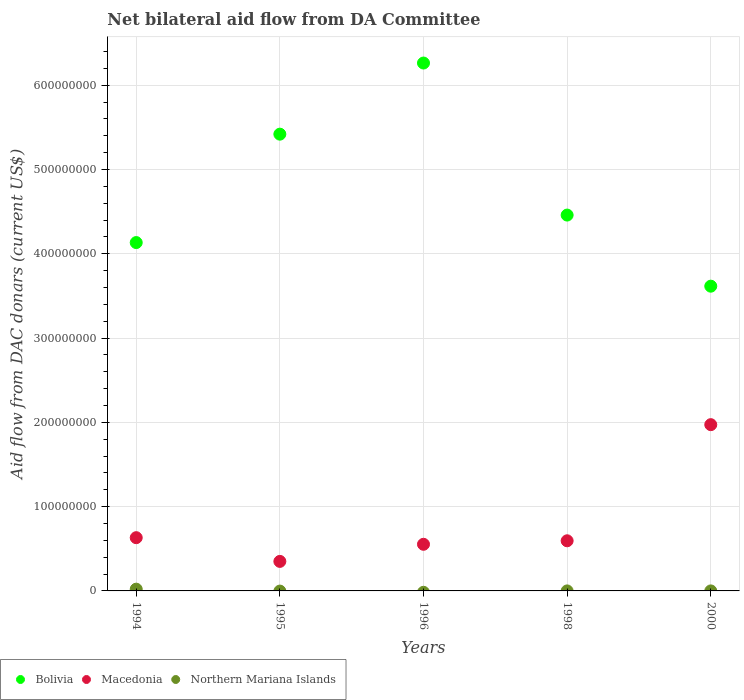How many different coloured dotlines are there?
Your answer should be compact. 3. What is the aid flow in in Bolivia in 1995?
Provide a succinct answer. 5.42e+08. Across all years, what is the maximum aid flow in in Macedonia?
Your answer should be compact. 1.97e+08. Across all years, what is the minimum aid flow in in Macedonia?
Your response must be concise. 3.50e+07. In which year was the aid flow in in Macedonia maximum?
Offer a very short reply. 2000. What is the total aid flow in in Bolivia in the graph?
Give a very brief answer. 2.39e+09. What is the difference between the aid flow in in Macedonia in 1994 and that in 2000?
Make the answer very short. -1.34e+08. What is the difference between the aid flow in in Northern Mariana Islands in 2000 and the aid flow in in Macedonia in 1996?
Keep it short and to the point. -5.53e+07. What is the average aid flow in in Macedonia per year?
Keep it short and to the point. 8.21e+07. In the year 1995, what is the difference between the aid flow in in Macedonia and aid flow in in Bolivia?
Provide a short and direct response. -5.07e+08. In how many years, is the aid flow in in Northern Mariana Islands greater than 440000000 US$?
Your answer should be very brief. 0. What is the ratio of the aid flow in in Bolivia in 1994 to that in 1995?
Your response must be concise. 0.76. Is the difference between the aid flow in in Macedonia in 1994 and 1995 greater than the difference between the aid flow in in Bolivia in 1994 and 1995?
Ensure brevity in your answer.  Yes. What is the difference between the highest and the second highest aid flow in in Northern Mariana Islands?
Provide a short and direct response. 2.07e+06. What is the difference between the highest and the lowest aid flow in in Northern Mariana Islands?
Your answer should be compact. 2.08e+06. Is the sum of the aid flow in in Bolivia in 1996 and 2000 greater than the maximum aid flow in in Northern Mariana Islands across all years?
Provide a short and direct response. Yes. Is the aid flow in in Northern Mariana Islands strictly less than the aid flow in in Bolivia over the years?
Ensure brevity in your answer.  Yes. How many dotlines are there?
Provide a short and direct response. 3. What is the difference between two consecutive major ticks on the Y-axis?
Provide a succinct answer. 1.00e+08. Does the graph contain grids?
Offer a terse response. Yes. Where does the legend appear in the graph?
Your answer should be very brief. Bottom left. How many legend labels are there?
Keep it short and to the point. 3. How are the legend labels stacked?
Provide a succinct answer. Horizontal. What is the title of the graph?
Give a very brief answer. Net bilateral aid flow from DA Committee. What is the label or title of the Y-axis?
Offer a very short reply. Aid flow from DAC donars (current US$). What is the Aid flow from DAC donars (current US$) of Bolivia in 1994?
Provide a succinct answer. 4.13e+08. What is the Aid flow from DAC donars (current US$) of Macedonia in 1994?
Provide a succinct answer. 6.32e+07. What is the Aid flow from DAC donars (current US$) of Northern Mariana Islands in 1994?
Your answer should be compact. 2.08e+06. What is the Aid flow from DAC donars (current US$) of Bolivia in 1995?
Keep it short and to the point. 5.42e+08. What is the Aid flow from DAC donars (current US$) in Macedonia in 1995?
Give a very brief answer. 3.50e+07. What is the Aid flow from DAC donars (current US$) of Bolivia in 1996?
Provide a short and direct response. 6.26e+08. What is the Aid flow from DAC donars (current US$) of Macedonia in 1996?
Offer a terse response. 5.53e+07. What is the Aid flow from DAC donars (current US$) in Bolivia in 1998?
Keep it short and to the point. 4.46e+08. What is the Aid flow from DAC donars (current US$) in Macedonia in 1998?
Give a very brief answer. 5.95e+07. What is the Aid flow from DAC donars (current US$) of Bolivia in 2000?
Provide a short and direct response. 3.62e+08. What is the Aid flow from DAC donars (current US$) of Macedonia in 2000?
Your answer should be compact. 1.97e+08. Across all years, what is the maximum Aid flow from DAC donars (current US$) in Bolivia?
Offer a terse response. 6.26e+08. Across all years, what is the maximum Aid flow from DAC donars (current US$) in Macedonia?
Offer a terse response. 1.97e+08. Across all years, what is the maximum Aid flow from DAC donars (current US$) of Northern Mariana Islands?
Provide a succinct answer. 2.08e+06. Across all years, what is the minimum Aid flow from DAC donars (current US$) in Bolivia?
Your answer should be very brief. 3.62e+08. Across all years, what is the minimum Aid flow from DAC donars (current US$) of Macedonia?
Your response must be concise. 3.50e+07. What is the total Aid flow from DAC donars (current US$) in Bolivia in the graph?
Offer a terse response. 2.39e+09. What is the total Aid flow from DAC donars (current US$) of Macedonia in the graph?
Your answer should be compact. 4.10e+08. What is the total Aid flow from DAC donars (current US$) of Northern Mariana Islands in the graph?
Provide a short and direct response. 2.10e+06. What is the difference between the Aid flow from DAC donars (current US$) of Bolivia in 1994 and that in 1995?
Provide a succinct answer. -1.29e+08. What is the difference between the Aid flow from DAC donars (current US$) in Macedonia in 1994 and that in 1995?
Make the answer very short. 2.82e+07. What is the difference between the Aid flow from DAC donars (current US$) in Bolivia in 1994 and that in 1996?
Provide a short and direct response. -2.13e+08. What is the difference between the Aid flow from DAC donars (current US$) in Macedonia in 1994 and that in 1996?
Offer a terse response. 7.84e+06. What is the difference between the Aid flow from DAC donars (current US$) in Bolivia in 1994 and that in 1998?
Make the answer very short. -3.26e+07. What is the difference between the Aid flow from DAC donars (current US$) in Macedonia in 1994 and that in 1998?
Provide a short and direct response. 3.69e+06. What is the difference between the Aid flow from DAC donars (current US$) in Northern Mariana Islands in 1994 and that in 1998?
Your answer should be compact. 2.07e+06. What is the difference between the Aid flow from DAC donars (current US$) in Bolivia in 1994 and that in 2000?
Offer a very short reply. 5.18e+07. What is the difference between the Aid flow from DAC donars (current US$) in Macedonia in 1994 and that in 2000?
Offer a terse response. -1.34e+08. What is the difference between the Aid flow from DAC donars (current US$) in Northern Mariana Islands in 1994 and that in 2000?
Your answer should be very brief. 2.07e+06. What is the difference between the Aid flow from DAC donars (current US$) in Bolivia in 1995 and that in 1996?
Provide a succinct answer. -8.44e+07. What is the difference between the Aid flow from DAC donars (current US$) of Macedonia in 1995 and that in 1996?
Keep it short and to the point. -2.03e+07. What is the difference between the Aid flow from DAC donars (current US$) of Bolivia in 1995 and that in 1998?
Provide a short and direct response. 9.60e+07. What is the difference between the Aid flow from DAC donars (current US$) of Macedonia in 1995 and that in 1998?
Your answer should be very brief. -2.45e+07. What is the difference between the Aid flow from DAC donars (current US$) of Bolivia in 1995 and that in 2000?
Offer a very short reply. 1.80e+08. What is the difference between the Aid flow from DAC donars (current US$) in Macedonia in 1995 and that in 2000?
Keep it short and to the point. -1.62e+08. What is the difference between the Aid flow from DAC donars (current US$) of Bolivia in 1996 and that in 1998?
Offer a very short reply. 1.80e+08. What is the difference between the Aid flow from DAC donars (current US$) in Macedonia in 1996 and that in 1998?
Your response must be concise. -4.15e+06. What is the difference between the Aid flow from DAC donars (current US$) of Bolivia in 1996 and that in 2000?
Your response must be concise. 2.65e+08. What is the difference between the Aid flow from DAC donars (current US$) in Macedonia in 1996 and that in 2000?
Offer a very short reply. -1.42e+08. What is the difference between the Aid flow from DAC donars (current US$) of Bolivia in 1998 and that in 2000?
Give a very brief answer. 8.44e+07. What is the difference between the Aid flow from DAC donars (current US$) of Macedonia in 1998 and that in 2000?
Offer a terse response. -1.38e+08. What is the difference between the Aid flow from DAC donars (current US$) in Bolivia in 1994 and the Aid flow from DAC donars (current US$) in Macedonia in 1995?
Give a very brief answer. 3.78e+08. What is the difference between the Aid flow from DAC donars (current US$) of Bolivia in 1994 and the Aid flow from DAC donars (current US$) of Macedonia in 1996?
Keep it short and to the point. 3.58e+08. What is the difference between the Aid flow from DAC donars (current US$) of Bolivia in 1994 and the Aid flow from DAC donars (current US$) of Macedonia in 1998?
Give a very brief answer. 3.54e+08. What is the difference between the Aid flow from DAC donars (current US$) of Bolivia in 1994 and the Aid flow from DAC donars (current US$) of Northern Mariana Islands in 1998?
Make the answer very short. 4.13e+08. What is the difference between the Aid flow from DAC donars (current US$) in Macedonia in 1994 and the Aid flow from DAC donars (current US$) in Northern Mariana Islands in 1998?
Give a very brief answer. 6.32e+07. What is the difference between the Aid flow from DAC donars (current US$) in Bolivia in 1994 and the Aid flow from DAC donars (current US$) in Macedonia in 2000?
Provide a succinct answer. 2.16e+08. What is the difference between the Aid flow from DAC donars (current US$) in Bolivia in 1994 and the Aid flow from DAC donars (current US$) in Northern Mariana Islands in 2000?
Your answer should be very brief. 4.13e+08. What is the difference between the Aid flow from DAC donars (current US$) in Macedonia in 1994 and the Aid flow from DAC donars (current US$) in Northern Mariana Islands in 2000?
Your response must be concise. 6.32e+07. What is the difference between the Aid flow from DAC donars (current US$) in Bolivia in 1995 and the Aid flow from DAC donars (current US$) in Macedonia in 1996?
Ensure brevity in your answer.  4.87e+08. What is the difference between the Aid flow from DAC donars (current US$) of Bolivia in 1995 and the Aid flow from DAC donars (current US$) of Macedonia in 1998?
Ensure brevity in your answer.  4.83e+08. What is the difference between the Aid flow from DAC donars (current US$) in Bolivia in 1995 and the Aid flow from DAC donars (current US$) in Northern Mariana Islands in 1998?
Keep it short and to the point. 5.42e+08. What is the difference between the Aid flow from DAC donars (current US$) of Macedonia in 1995 and the Aid flow from DAC donars (current US$) of Northern Mariana Islands in 1998?
Provide a succinct answer. 3.50e+07. What is the difference between the Aid flow from DAC donars (current US$) in Bolivia in 1995 and the Aid flow from DAC donars (current US$) in Macedonia in 2000?
Your answer should be very brief. 3.45e+08. What is the difference between the Aid flow from DAC donars (current US$) in Bolivia in 1995 and the Aid flow from DAC donars (current US$) in Northern Mariana Islands in 2000?
Your answer should be very brief. 5.42e+08. What is the difference between the Aid flow from DAC donars (current US$) of Macedonia in 1995 and the Aid flow from DAC donars (current US$) of Northern Mariana Islands in 2000?
Make the answer very short. 3.50e+07. What is the difference between the Aid flow from DAC donars (current US$) in Bolivia in 1996 and the Aid flow from DAC donars (current US$) in Macedonia in 1998?
Offer a terse response. 5.67e+08. What is the difference between the Aid flow from DAC donars (current US$) in Bolivia in 1996 and the Aid flow from DAC donars (current US$) in Northern Mariana Islands in 1998?
Provide a succinct answer. 6.26e+08. What is the difference between the Aid flow from DAC donars (current US$) of Macedonia in 1996 and the Aid flow from DAC donars (current US$) of Northern Mariana Islands in 1998?
Provide a short and direct response. 5.53e+07. What is the difference between the Aid flow from DAC donars (current US$) in Bolivia in 1996 and the Aid flow from DAC donars (current US$) in Macedonia in 2000?
Make the answer very short. 4.29e+08. What is the difference between the Aid flow from DAC donars (current US$) of Bolivia in 1996 and the Aid flow from DAC donars (current US$) of Northern Mariana Islands in 2000?
Keep it short and to the point. 6.26e+08. What is the difference between the Aid flow from DAC donars (current US$) in Macedonia in 1996 and the Aid flow from DAC donars (current US$) in Northern Mariana Islands in 2000?
Make the answer very short. 5.53e+07. What is the difference between the Aid flow from DAC donars (current US$) in Bolivia in 1998 and the Aid flow from DAC donars (current US$) in Macedonia in 2000?
Ensure brevity in your answer.  2.49e+08. What is the difference between the Aid flow from DAC donars (current US$) of Bolivia in 1998 and the Aid flow from DAC donars (current US$) of Northern Mariana Islands in 2000?
Ensure brevity in your answer.  4.46e+08. What is the difference between the Aid flow from DAC donars (current US$) of Macedonia in 1998 and the Aid flow from DAC donars (current US$) of Northern Mariana Islands in 2000?
Your response must be concise. 5.95e+07. What is the average Aid flow from DAC donars (current US$) of Bolivia per year?
Offer a very short reply. 4.78e+08. What is the average Aid flow from DAC donars (current US$) of Macedonia per year?
Make the answer very short. 8.21e+07. What is the average Aid flow from DAC donars (current US$) in Northern Mariana Islands per year?
Ensure brevity in your answer.  4.20e+05. In the year 1994, what is the difference between the Aid flow from DAC donars (current US$) in Bolivia and Aid flow from DAC donars (current US$) in Macedonia?
Your answer should be compact. 3.50e+08. In the year 1994, what is the difference between the Aid flow from DAC donars (current US$) in Bolivia and Aid flow from DAC donars (current US$) in Northern Mariana Islands?
Ensure brevity in your answer.  4.11e+08. In the year 1994, what is the difference between the Aid flow from DAC donars (current US$) in Macedonia and Aid flow from DAC donars (current US$) in Northern Mariana Islands?
Provide a succinct answer. 6.11e+07. In the year 1995, what is the difference between the Aid flow from DAC donars (current US$) in Bolivia and Aid flow from DAC donars (current US$) in Macedonia?
Offer a very short reply. 5.07e+08. In the year 1996, what is the difference between the Aid flow from DAC donars (current US$) in Bolivia and Aid flow from DAC donars (current US$) in Macedonia?
Your response must be concise. 5.71e+08. In the year 1998, what is the difference between the Aid flow from DAC donars (current US$) of Bolivia and Aid flow from DAC donars (current US$) of Macedonia?
Offer a very short reply. 3.86e+08. In the year 1998, what is the difference between the Aid flow from DAC donars (current US$) of Bolivia and Aid flow from DAC donars (current US$) of Northern Mariana Islands?
Provide a succinct answer. 4.46e+08. In the year 1998, what is the difference between the Aid flow from DAC donars (current US$) of Macedonia and Aid flow from DAC donars (current US$) of Northern Mariana Islands?
Your response must be concise. 5.95e+07. In the year 2000, what is the difference between the Aid flow from DAC donars (current US$) in Bolivia and Aid flow from DAC donars (current US$) in Macedonia?
Offer a terse response. 1.64e+08. In the year 2000, what is the difference between the Aid flow from DAC donars (current US$) in Bolivia and Aid flow from DAC donars (current US$) in Northern Mariana Islands?
Offer a terse response. 3.62e+08. In the year 2000, what is the difference between the Aid flow from DAC donars (current US$) of Macedonia and Aid flow from DAC donars (current US$) of Northern Mariana Islands?
Ensure brevity in your answer.  1.97e+08. What is the ratio of the Aid flow from DAC donars (current US$) in Bolivia in 1994 to that in 1995?
Offer a very short reply. 0.76. What is the ratio of the Aid flow from DAC donars (current US$) of Macedonia in 1994 to that in 1995?
Your answer should be compact. 1.8. What is the ratio of the Aid flow from DAC donars (current US$) in Bolivia in 1994 to that in 1996?
Ensure brevity in your answer.  0.66. What is the ratio of the Aid flow from DAC donars (current US$) of Macedonia in 1994 to that in 1996?
Offer a very short reply. 1.14. What is the ratio of the Aid flow from DAC donars (current US$) in Bolivia in 1994 to that in 1998?
Your answer should be very brief. 0.93. What is the ratio of the Aid flow from DAC donars (current US$) of Macedonia in 1994 to that in 1998?
Your response must be concise. 1.06. What is the ratio of the Aid flow from DAC donars (current US$) of Northern Mariana Islands in 1994 to that in 1998?
Your response must be concise. 208. What is the ratio of the Aid flow from DAC donars (current US$) of Bolivia in 1994 to that in 2000?
Keep it short and to the point. 1.14. What is the ratio of the Aid flow from DAC donars (current US$) of Macedonia in 1994 to that in 2000?
Keep it short and to the point. 0.32. What is the ratio of the Aid flow from DAC donars (current US$) of Northern Mariana Islands in 1994 to that in 2000?
Keep it short and to the point. 208. What is the ratio of the Aid flow from DAC donars (current US$) in Bolivia in 1995 to that in 1996?
Offer a very short reply. 0.87. What is the ratio of the Aid flow from DAC donars (current US$) of Macedonia in 1995 to that in 1996?
Provide a short and direct response. 0.63. What is the ratio of the Aid flow from DAC donars (current US$) in Bolivia in 1995 to that in 1998?
Your answer should be very brief. 1.22. What is the ratio of the Aid flow from DAC donars (current US$) of Macedonia in 1995 to that in 1998?
Your answer should be compact. 0.59. What is the ratio of the Aid flow from DAC donars (current US$) of Bolivia in 1995 to that in 2000?
Provide a succinct answer. 1.5. What is the ratio of the Aid flow from DAC donars (current US$) of Macedonia in 1995 to that in 2000?
Give a very brief answer. 0.18. What is the ratio of the Aid flow from DAC donars (current US$) in Bolivia in 1996 to that in 1998?
Keep it short and to the point. 1.4. What is the ratio of the Aid flow from DAC donars (current US$) of Macedonia in 1996 to that in 1998?
Your response must be concise. 0.93. What is the ratio of the Aid flow from DAC donars (current US$) in Bolivia in 1996 to that in 2000?
Your answer should be compact. 1.73. What is the ratio of the Aid flow from DAC donars (current US$) in Macedonia in 1996 to that in 2000?
Provide a short and direct response. 0.28. What is the ratio of the Aid flow from DAC donars (current US$) in Bolivia in 1998 to that in 2000?
Offer a very short reply. 1.23. What is the ratio of the Aid flow from DAC donars (current US$) in Macedonia in 1998 to that in 2000?
Your answer should be compact. 0.3. What is the difference between the highest and the second highest Aid flow from DAC donars (current US$) of Bolivia?
Give a very brief answer. 8.44e+07. What is the difference between the highest and the second highest Aid flow from DAC donars (current US$) of Macedonia?
Provide a succinct answer. 1.34e+08. What is the difference between the highest and the second highest Aid flow from DAC donars (current US$) of Northern Mariana Islands?
Your response must be concise. 2.07e+06. What is the difference between the highest and the lowest Aid flow from DAC donars (current US$) of Bolivia?
Make the answer very short. 2.65e+08. What is the difference between the highest and the lowest Aid flow from DAC donars (current US$) of Macedonia?
Offer a terse response. 1.62e+08. What is the difference between the highest and the lowest Aid flow from DAC donars (current US$) of Northern Mariana Islands?
Provide a succinct answer. 2.08e+06. 